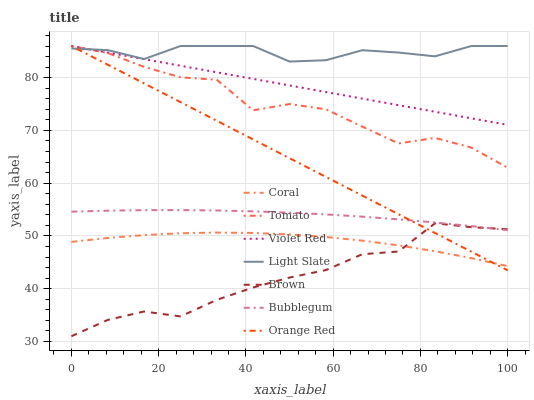Does Brown have the minimum area under the curve?
Answer yes or no. Yes. Does Light Slate have the maximum area under the curve?
Answer yes or no. Yes. Does Violet Red have the minimum area under the curve?
Answer yes or no. No. Does Violet Red have the maximum area under the curve?
Answer yes or no. No. Is Violet Red the smoothest?
Answer yes or no. Yes. Is Tomato the roughest?
Answer yes or no. Yes. Is Brown the smoothest?
Answer yes or no. No. Is Brown the roughest?
Answer yes or no. No. Does Brown have the lowest value?
Answer yes or no. Yes. Does Violet Red have the lowest value?
Answer yes or no. No. Does Orange Red have the highest value?
Answer yes or no. Yes. Does Brown have the highest value?
Answer yes or no. No. Is Bubblegum less than Light Slate?
Answer yes or no. Yes. Is Light Slate greater than Bubblegum?
Answer yes or no. Yes. Does Violet Red intersect Light Slate?
Answer yes or no. Yes. Is Violet Red less than Light Slate?
Answer yes or no. No. Is Violet Red greater than Light Slate?
Answer yes or no. No. Does Bubblegum intersect Light Slate?
Answer yes or no. No. 